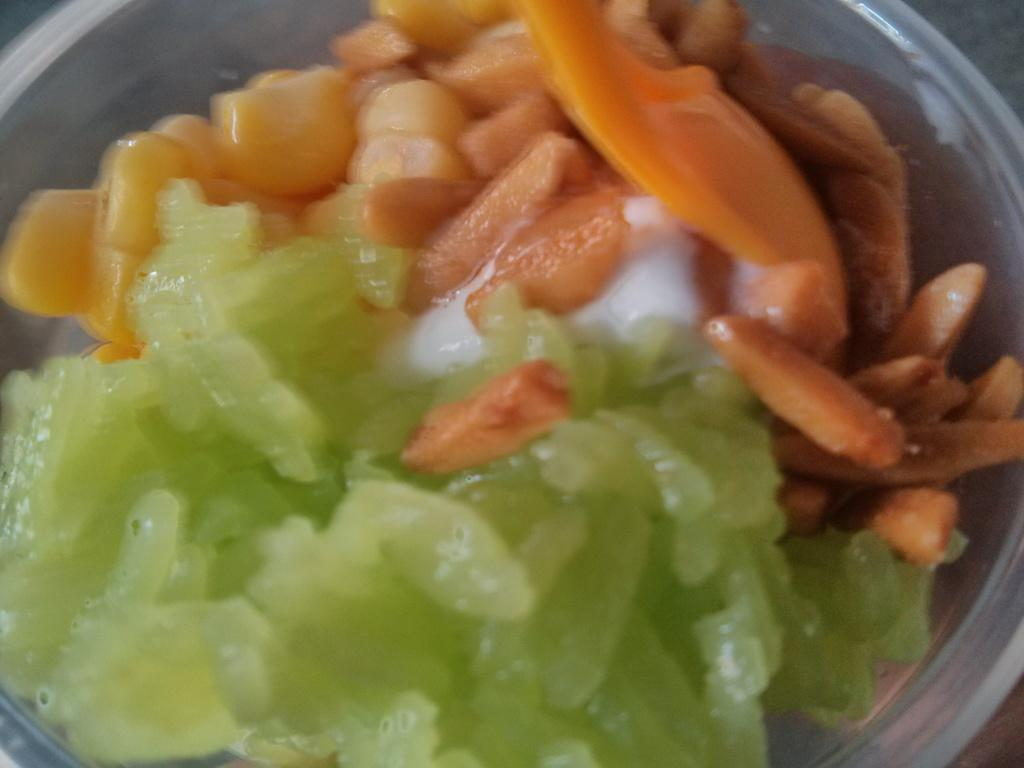What is present in the image? There is a bowl in the image. What is inside the bowl? There is a food item in the bowl. Can you hear a whistle in the image? There is no whistle present in the image. How many ladybugs can be seen in the image? There are no ladybugs present in the image. 